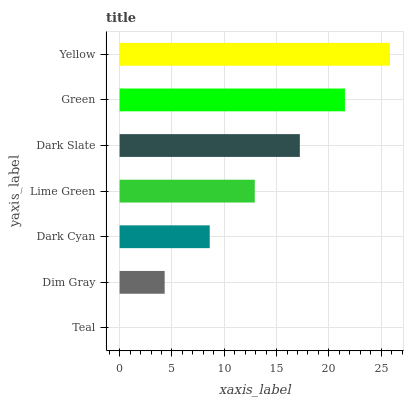Is Teal the minimum?
Answer yes or no. Yes. Is Yellow the maximum?
Answer yes or no. Yes. Is Dim Gray the minimum?
Answer yes or no. No. Is Dim Gray the maximum?
Answer yes or no. No. Is Dim Gray greater than Teal?
Answer yes or no. Yes. Is Teal less than Dim Gray?
Answer yes or no. Yes. Is Teal greater than Dim Gray?
Answer yes or no. No. Is Dim Gray less than Teal?
Answer yes or no. No. Is Lime Green the high median?
Answer yes or no. Yes. Is Lime Green the low median?
Answer yes or no. Yes. Is Dark Slate the high median?
Answer yes or no. No. Is Dark Slate the low median?
Answer yes or no. No. 